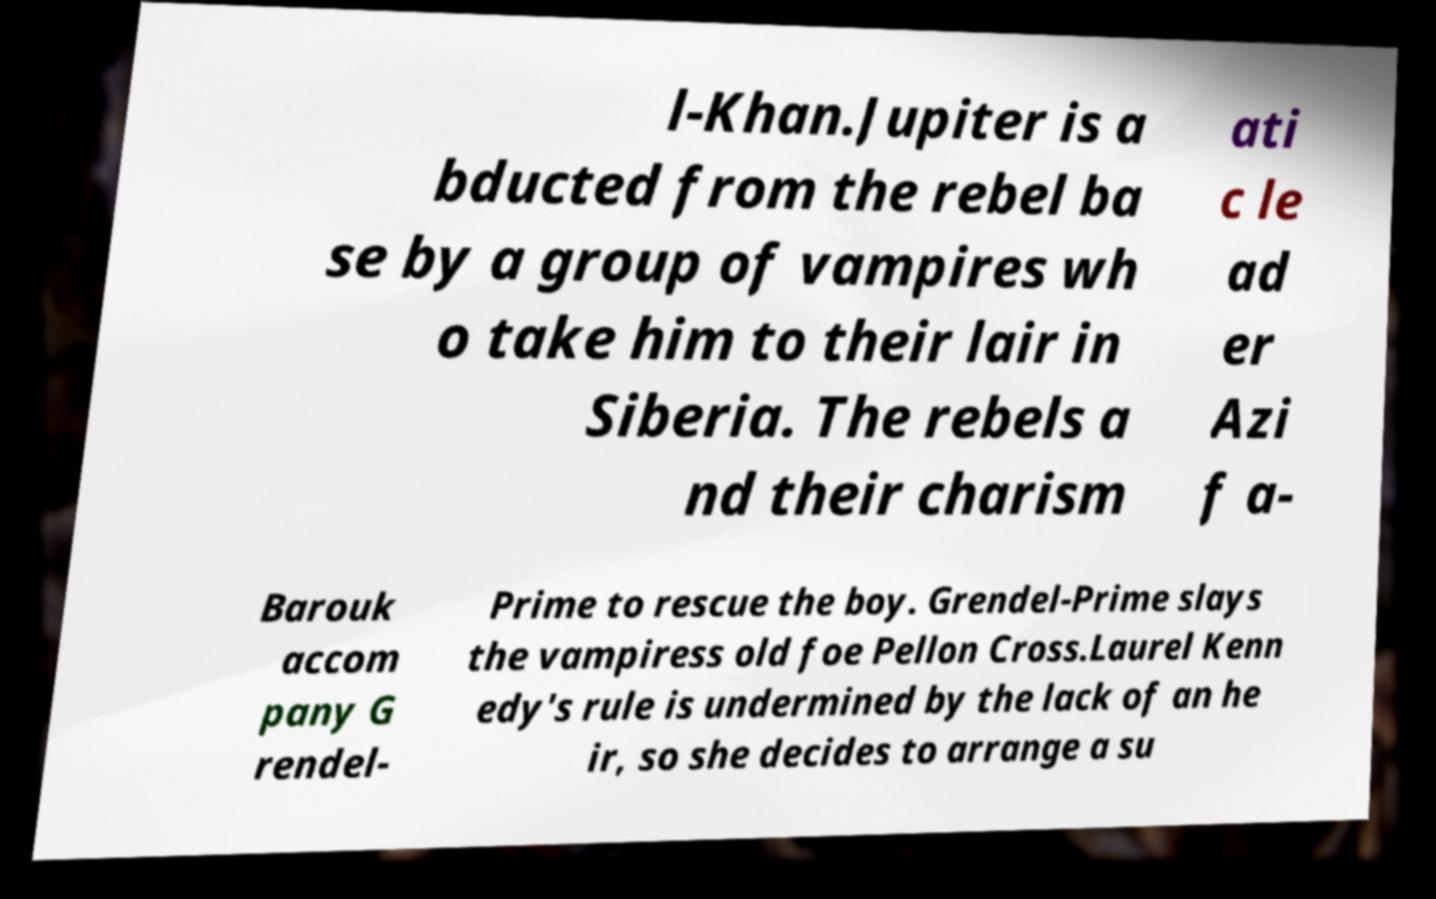I need the written content from this picture converted into text. Can you do that? l-Khan.Jupiter is a bducted from the rebel ba se by a group of vampires wh o take him to their lair in Siberia. The rebels a nd their charism ati c le ad er Azi f a- Barouk accom pany G rendel- Prime to rescue the boy. Grendel-Prime slays the vampiress old foe Pellon Cross.Laurel Kenn edy's rule is undermined by the lack of an he ir, so she decides to arrange a su 